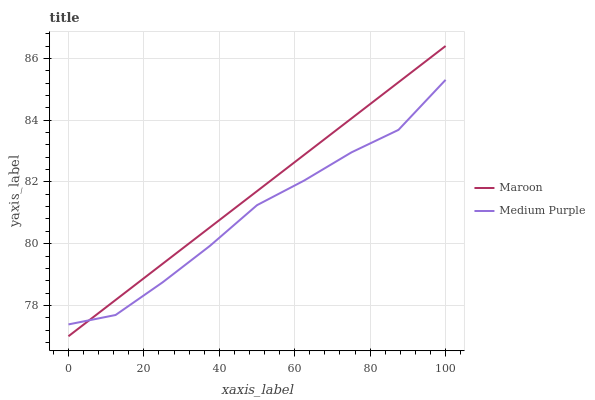Does Maroon have the minimum area under the curve?
Answer yes or no. No. Is Maroon the roughest?
Answer yes or no. No. 